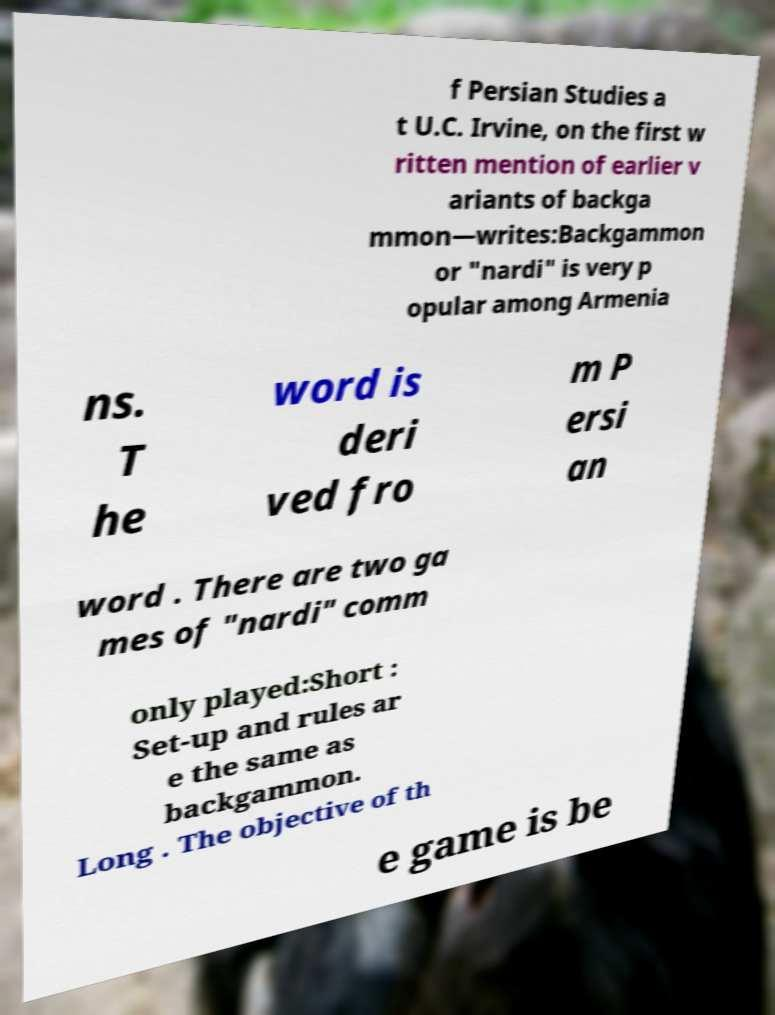For documentation purposes, I need the text within this image transcribed. Could you provide that? f Persian Studies a t U.C. Irvine, on the first w ritten mention of earlier v ariants of backga mmon—writes:Backgammon or "nardi" is very p opular among Armenia ns. T he word is deri ved fro m P ersi an word . There are two ga mes of "nardi" comm only played:Short : Set-up and rules ar e the same as backgammon. Long . The objective of th e game is be 